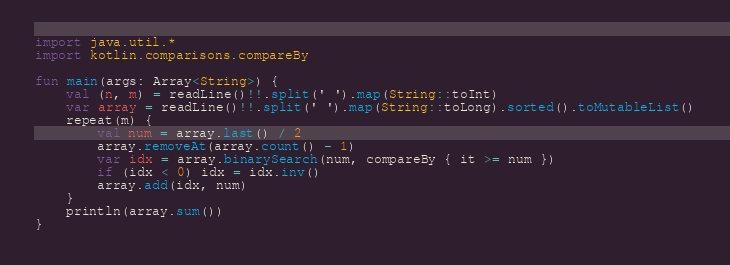<code> <loc_0><loc_0><loc_500><loc_500><_Kotlin_>import java.util.*
import kotlin.comparisons.compareBy

fun main(args: Array<String>) {
    val (n, m) = readLine()!!.split(' ').map(String::toInt)
    var array = readLine()!!.split(' ').map(String::toLong).sorted().toMutableList()
    repeat(m) {
        val num = array.last() / 2
        array.removeAt(array.count() - 1)
        var idx = array.binarySearch(num, compareBy { it >= num })
        if (idx < 0) idx = idx.inv()
        array.add(idx, num)
    }
    println(array.sum())
}
</code> 